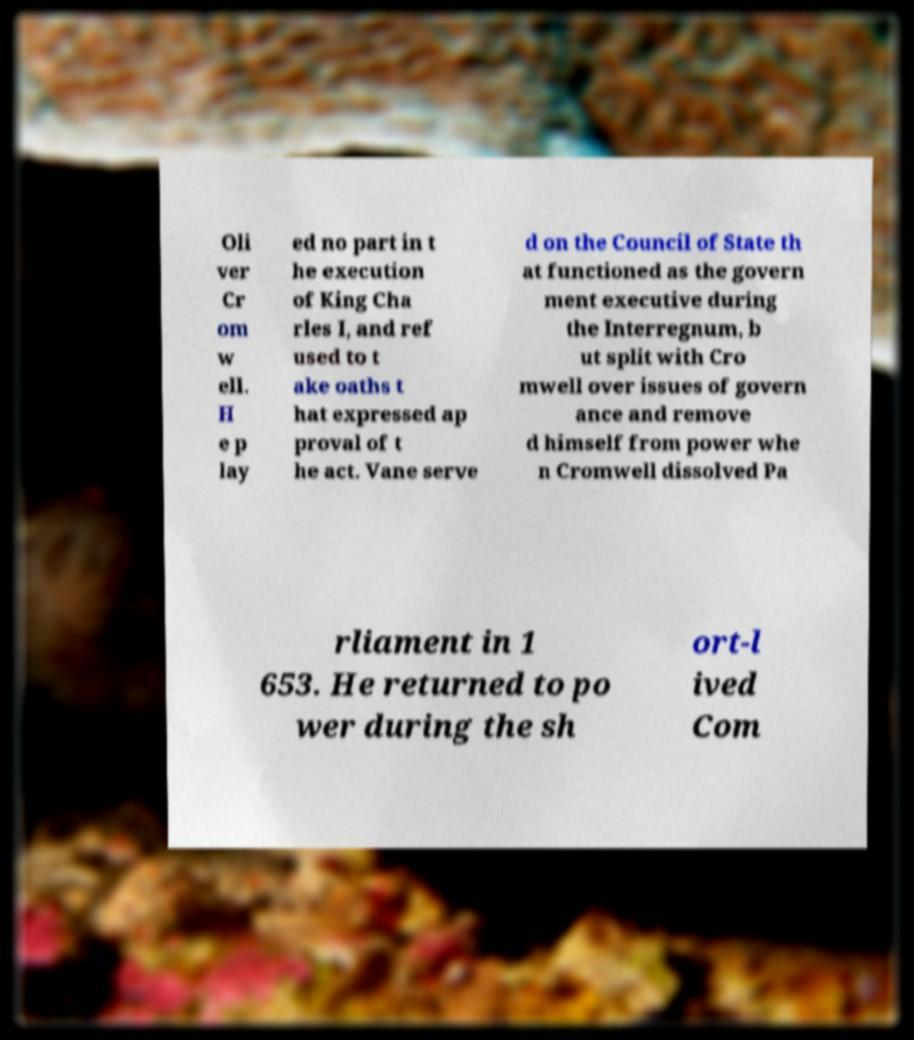Could you assist in decoding the text presented in this image and type it out clearly? Oli ver Cr om w ell. H e p lay ed no part in t he execution of King Cha rles I, and ref used to t ake oaths t hat expressed ap proval of t he act. Vane serve d on the Council of State th at functioned as the govern ment executive during the Interregnum, b ut split with Cro mwell over issues of govern ance and remove d himself from power whe n Cromwell dissolved Pa rliament in 1 653. He returned to po wer during the sh ort-l ived Com 